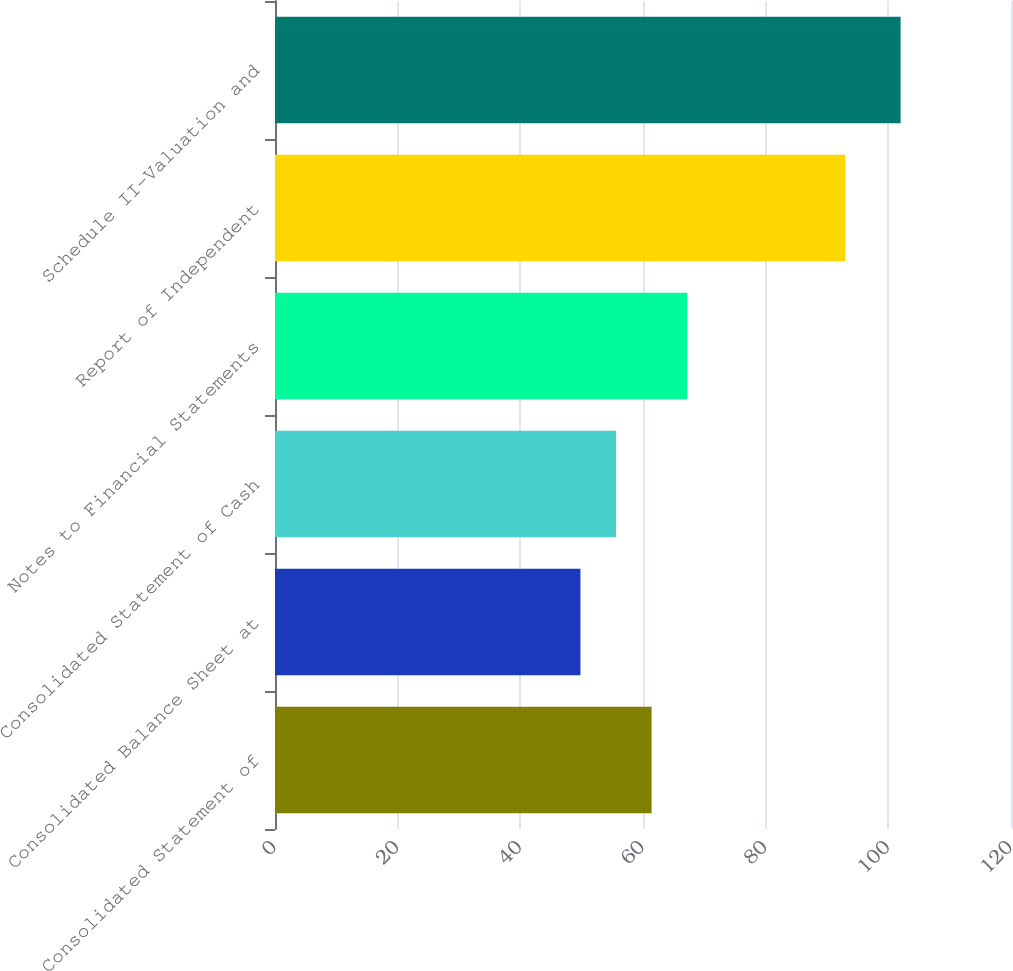Convert chart. <chart><loc_0><loc_0><loc_500><loc_500><bar_chart><fcel>Consolidated Statement of<fcel>Consolidated Balance Sheet at<fcel>Consolidated Statement of Cash<fcel>Notes to Financial Statements<fcel>Report of Independent<fcel>Schedule II-Valuation and<nl><fcel>61.4<fcel>49.8<fcel>55.6<fcel>67.2<fcel>93<fcel>102<nl></chart> 